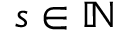Convert formula to latex. <formula><loc_0><loc_0><loc_500><loc_500>s \in \mathbb { N }</formula> 